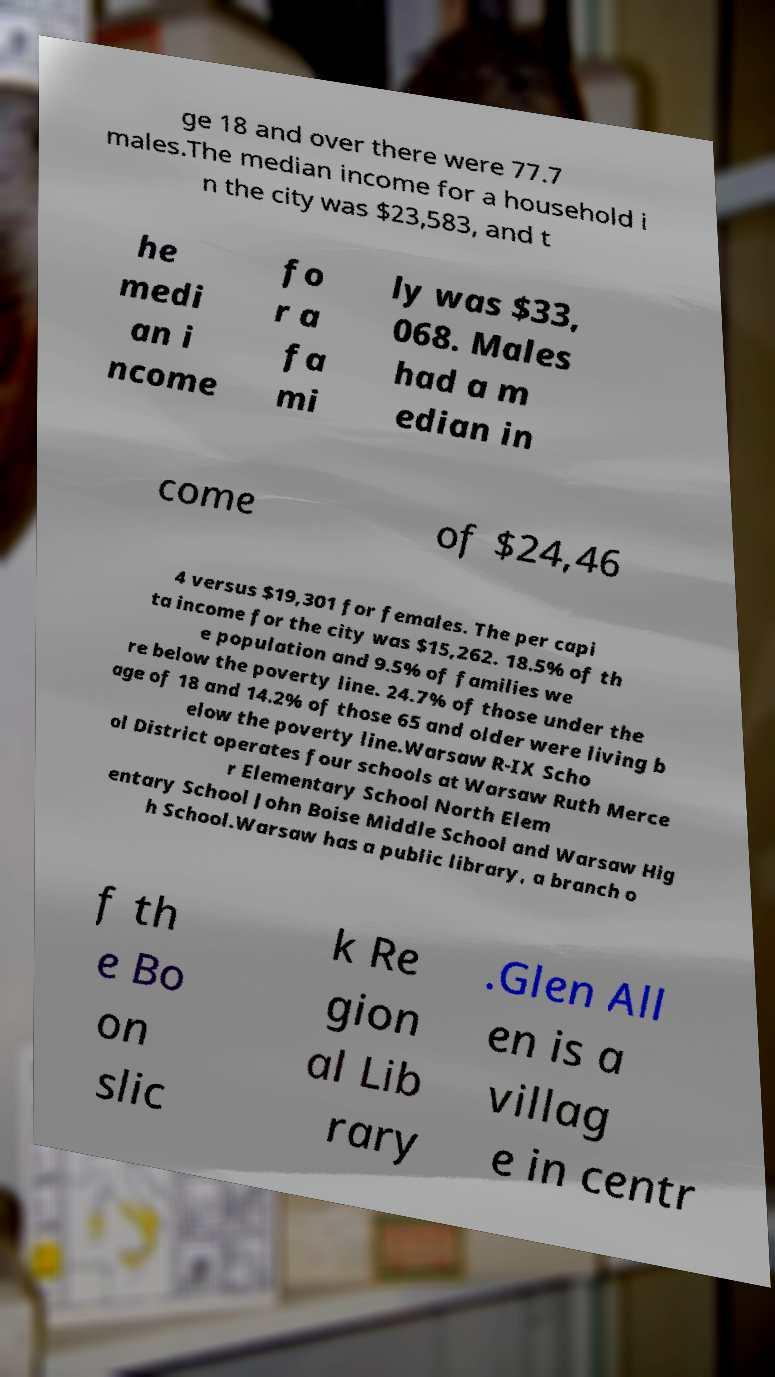What messages or text are displayed in this image? I need them in a readable, typed format. ge 18 and over there were 77.7 males.The median income for a household i n the city was $23,583, and t he medi an i ncome fo r a fa mi ly was $33, 068. Males had a m edian in come of $24,46 4 versus $19,301 for females. The per capi ta income for the city was $15,262. 18.5% of th e population and 9.5% of families we re below the poverty line. 24.7% of those under the age of 18 and 14.2% of those 65 and older were living b elow the poverty line.Warsaw R-IX Scho ol District operates four schools at Warsaw Ruth Merce r Elementary School North Elem entary School John Boise Middle School and Warsaw Hig h School.Warsaw has a public library, a branch o f th e Bo on slic k Re gion al Lib rary .Glen All en is a villag e in centr 